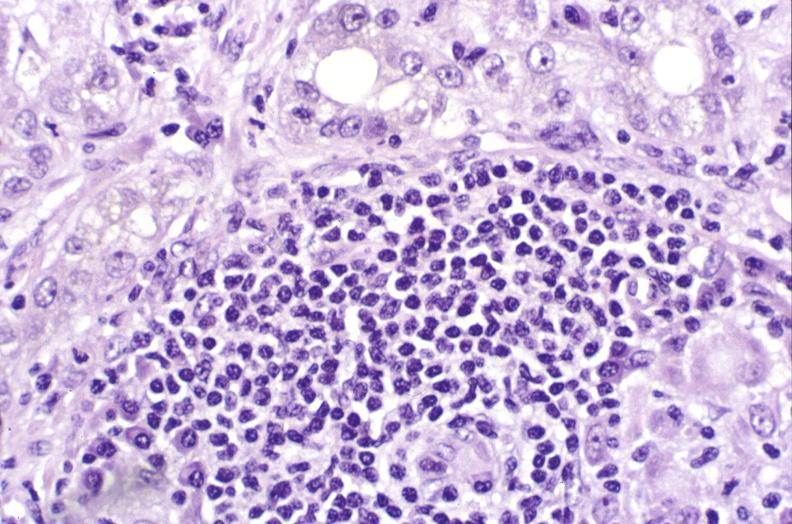s liver present?
Answer the question using a single word or phrase. Yes 